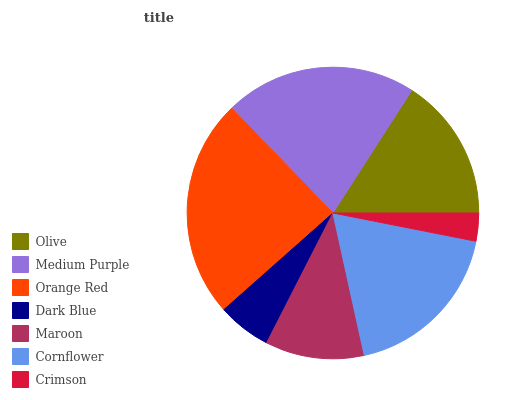Is Crimson the minimum?
Answer yes or no. Yes. Is Orange Red the maximum?
Answer yes or no. Yes. Is Medium Purple the minimum?
Answer yes or no. No. Is Medium Purple the maximum?
Answer yes or no. No. Is Medium Purple greater than Olive?
Answer yes or no. Yes. Is Olive less than Medium Purple?
Answer yes or no. Yes. Is Olive greater than Medium Purple?
Answer yes or no. No. Is Medium Purple less than Olive?
Answer yes or no. No. Is Olive the high median?
Answer yes or no. Yes. Is Olive the low median?
Answer yes or no. Yes. Is Cornflower the high median?
Answer yes or no. No. Is Cornflower the low median?
Answer yes or no. No. 